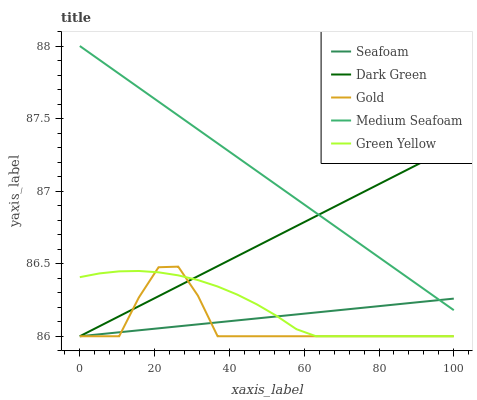Does Green Yellow have the minimum area under the curve?
Answer yes or no. No. Does Green Yellow have the maximum area under the curve?
Answer yes or no. No. Is Green Yellow the smoothest?
Answer yes or no. No. Is Green Yellow the roughest?
Answer yes or no. No. Does Green Yellow have the highest value?
Answer yes or no. No. Is Green Yellow less than Medium Seafoam?
Answer yes or no. Yes. Is Medium Seafoam greater than Green Yellow?
Answer yes or no. Yes. Does Green Yellow intersect Medium Seafoam?
Answer yes or no. No. 